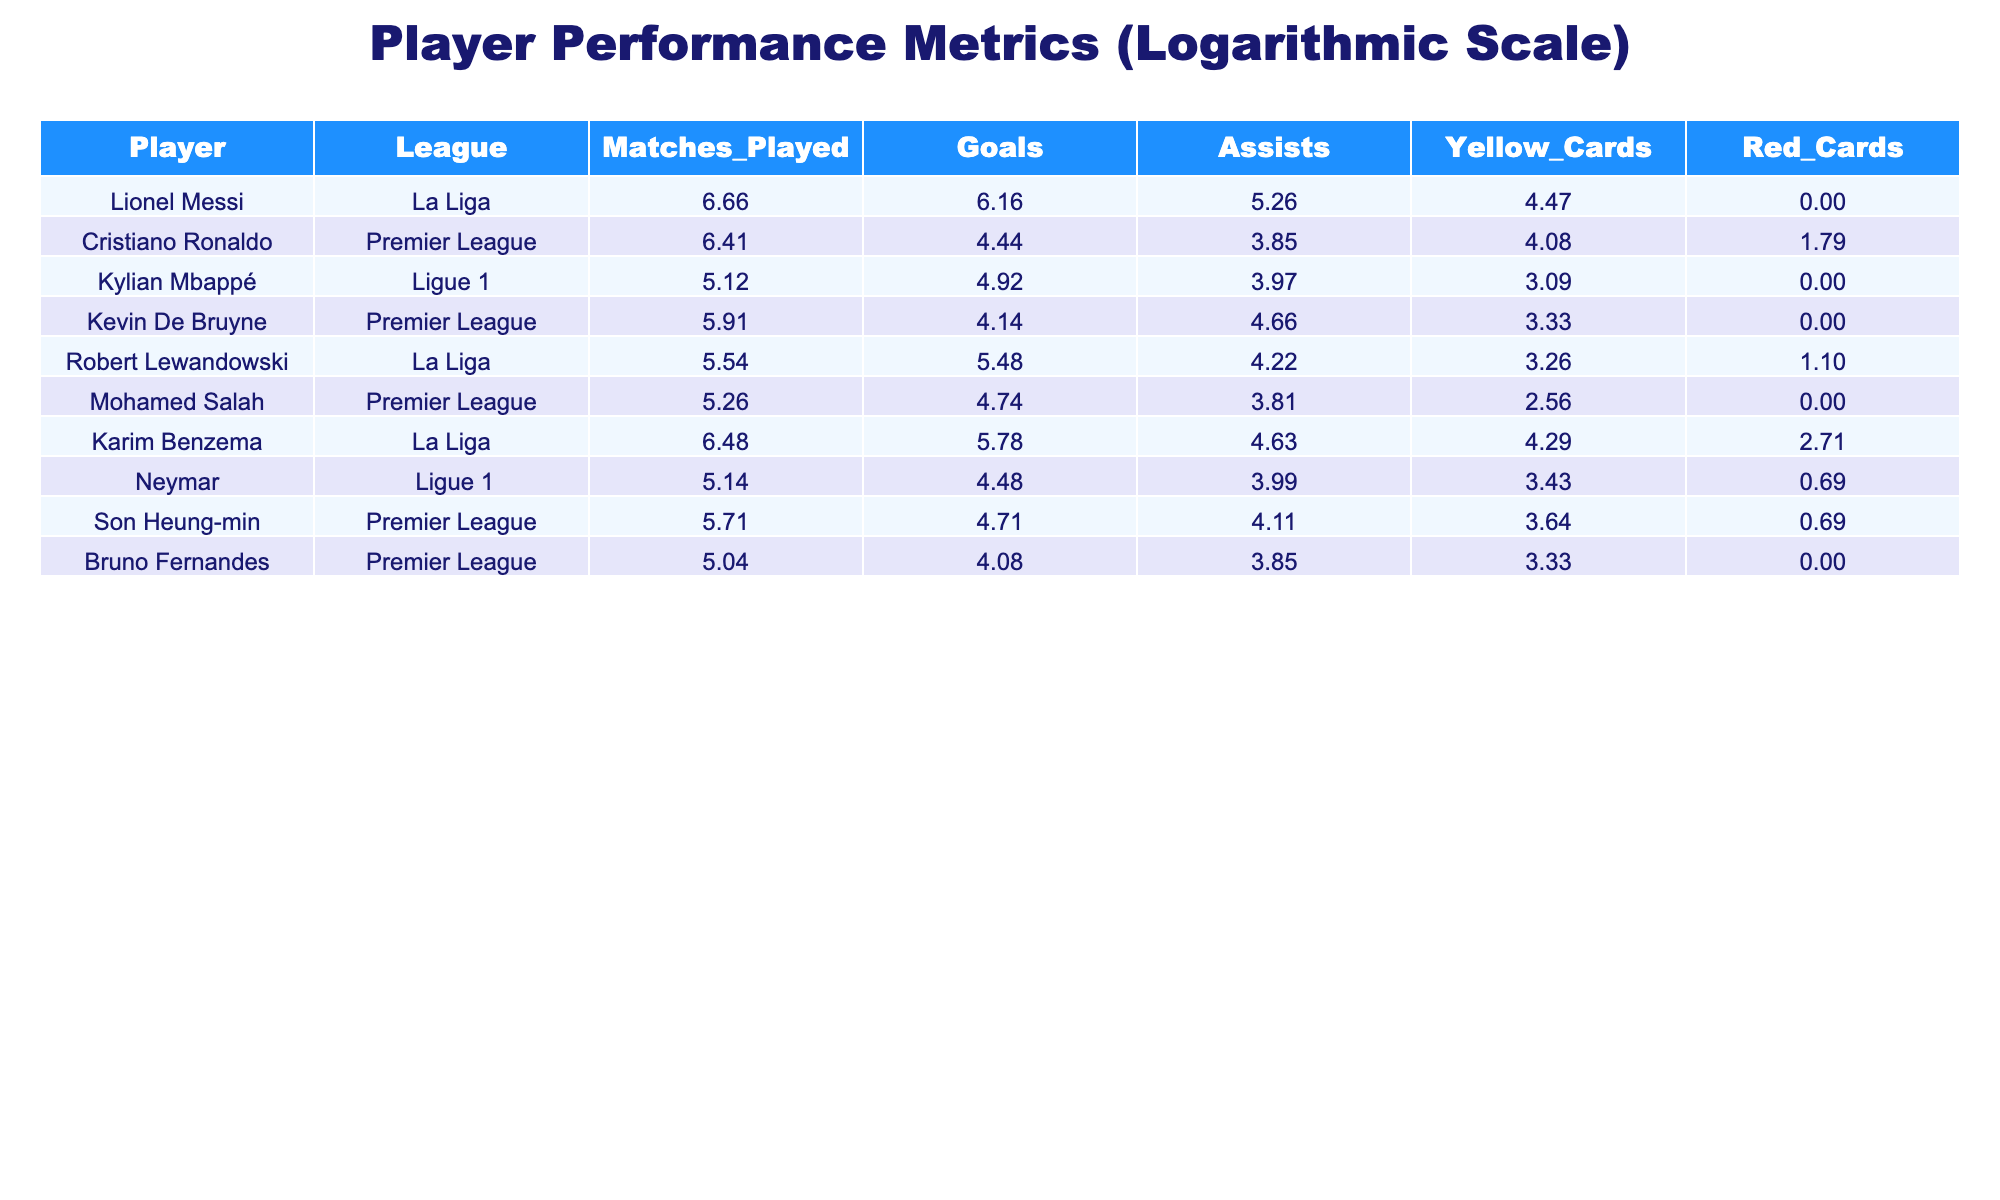What is the total number of goals scored by Lionel Messi and Robert Lewandowski combined? Lionel Messi scored 474 goals and Robert Lewandowski scored 238 goals. Adding these gives us a total of 474 + 238 = 712 goals.
Answer: 712 Which player has the highest number of assists in the Premier League? Kevin De Bruyne has the highest number of assists in the Premier League with 105 assists.
Answer: 105 Did Kylian Mbappé receive any red cards during his matches? Looking at the table, Kylian Mbappé has 0 red cards indicated, which means he did not receive any.
Answer: No What is the difference in the number of yellow cards between Mohamed Salah and Son Heung-min? Mohamed Salah has 12 yellow cards and Son Heung-min has 37 yellow cards. The difference is calculated as 37 - 12 = 25 yellow cards.
Answer: 25 Which league has the player with the highest total goals? In La Liga, Lionel Messi scored 474 goals, and Robert Lewandowski scored 238 goals, making a combined total of 712 goals, which is the highest compared to players in other leagues.
Answer: La Liga What is the average number of matches played by players from Ligue 1? Kylian Mbappé played 167 matches, and Neymar played 170 matches in Ligue 1. The average is calculated as (167 + 170) / 2 = 168.5 matches.
Answer: 168.5 Is it true that Cristiano Ronaldo has more yellow cards than Kevin De Bruyne? Cristiano Ronaldo has 58 yellow cards and Kevin De Bruyne has 27 yellow cards. Since 58 is greater than 27, the statement is true.
Answer: Yes What is the combined total of goals and assists for Karim Benzema? Karim Benzema scored 324 goals and provided 102 assists. The combined total is 324 + 102 = 426.
Answer: 426 Which player has the lowest number of matches played in Ligue 1? In Ligue 1, Kylian Mbappé played 167 matches and Neymar played 170 matches. Thus, Kylian Mbappé has the lowest number of matches played.
Answer: Kylian Mbappé 